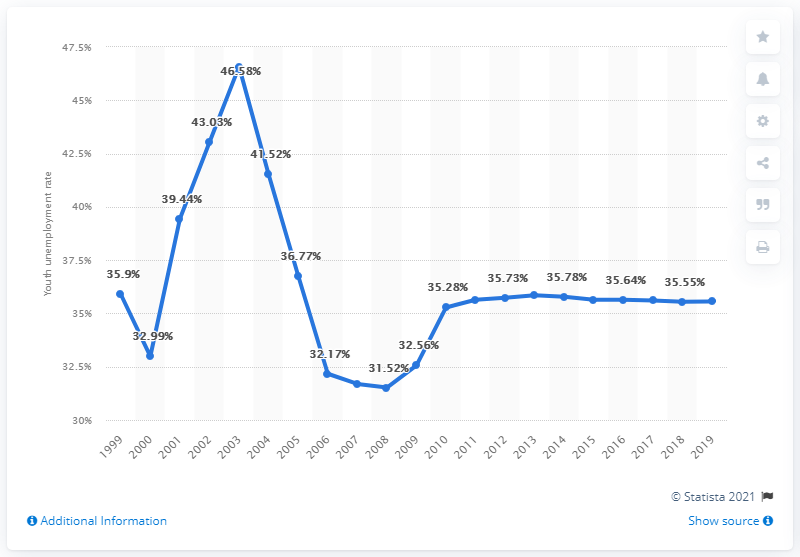List a handful of essential elements in this visual. In 2019, the youth unemployment rate in Botswana was 35.56%. 